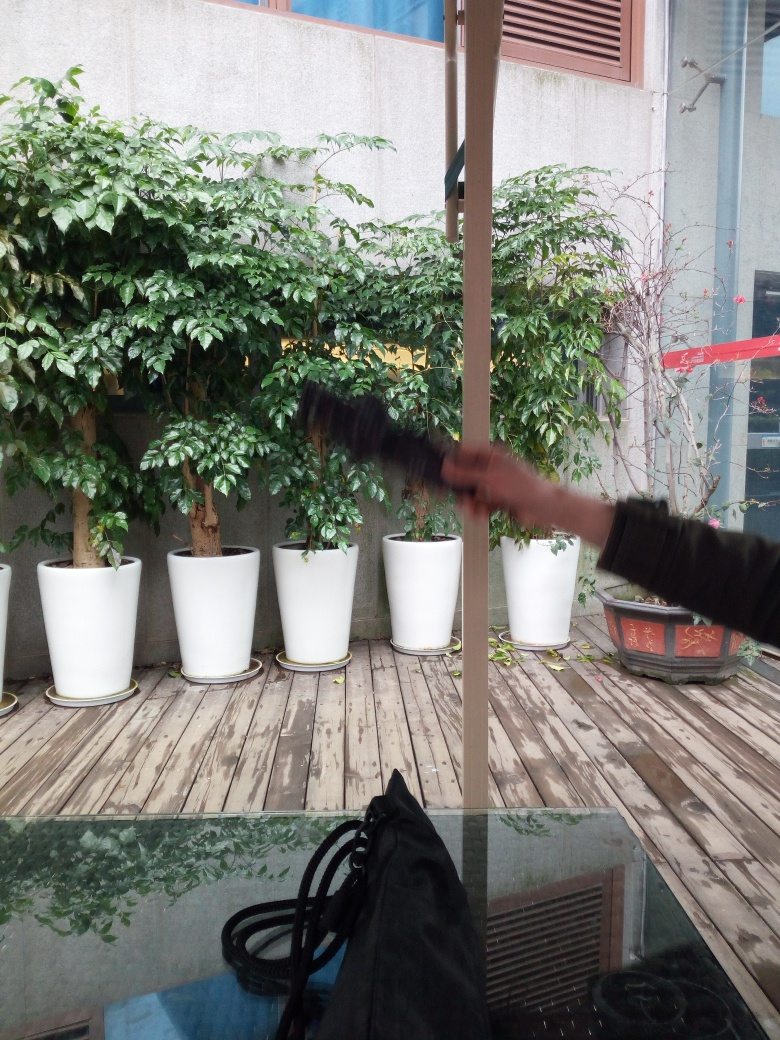What time of day does this image look like it was taken? Given the natural lighting conditions and the shadows present on the wooden deck, it appears to be midday, with the sun positioned to cast a softer light that isn't producing harsh shadows. 